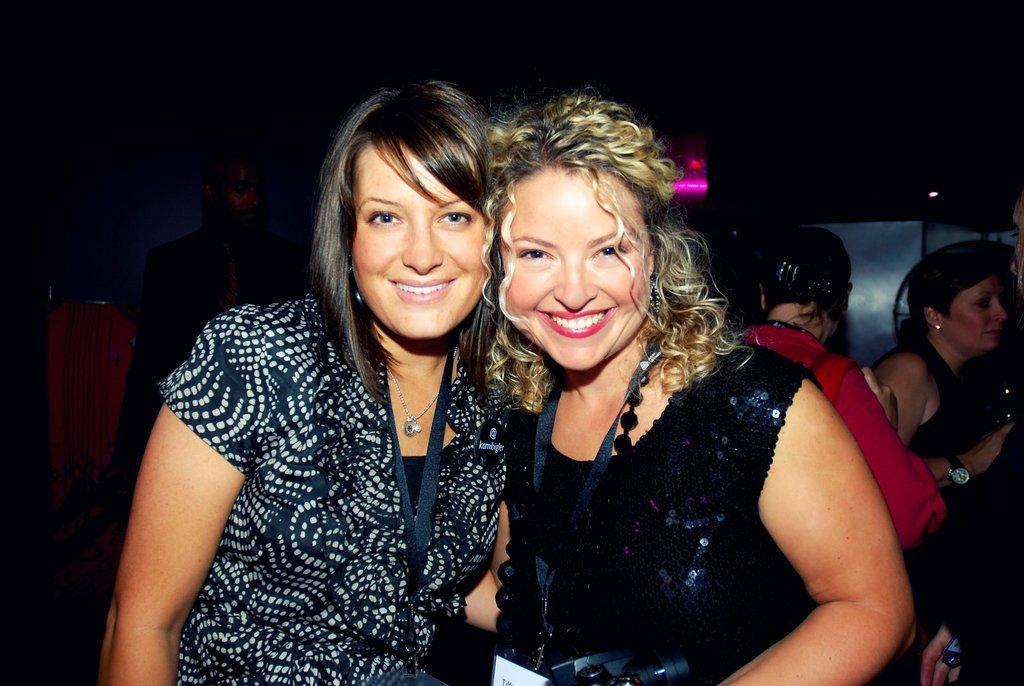In one or two sentences, can you explain what this image depicts? In front of the picture, we see two women who are wearing black dresses are standing. They are smiling. They are wearing ID cards and they are posing for the photo. Behind them, we see people are standing. Behind them, we see something in white color. In the background, it is black in color. 